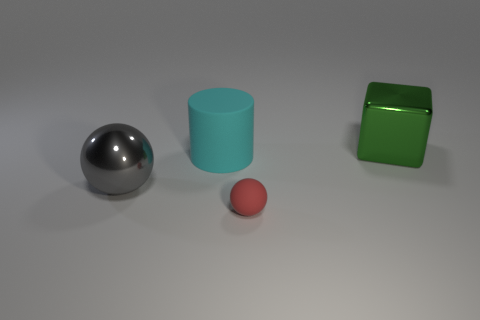Are there more cubes that are on the left side of the red sphere than large brown spheres?
Your answer should be very brief. No. There is a metal block that is the same size as the gray sphere; what color is it?
Provide a succinct answer. Green. What number of objects are either big objects that are to the left of the large cube or blue cubes?
Your answer should be compact. 2. What material is the object in front of the sphere behind the small sphere?
Make the answer very short. Rubber. Is there a cyan object that has the same material as the tiny red ball?
Give a very brief answer. Yes. Are there any small red matte things left of the matte thing that is to the right of the cyan rubber object?
Provide a succinct answer. No. There is a ball in front of the big gray sphere; what is it made of?
Offer a very short reply. Rubber. Is the tiny rubber object the same shape as the green shiny object?
Your answer should be compact. No. There is a large shiny thing that is on the left side of the sphere in front of the shiny object that is in front of the green metal object; what color is it?
Make the answer very short. Gray. What number of other tiny things have the same shape as the cyan thing?
Offer a terse response. 0. 